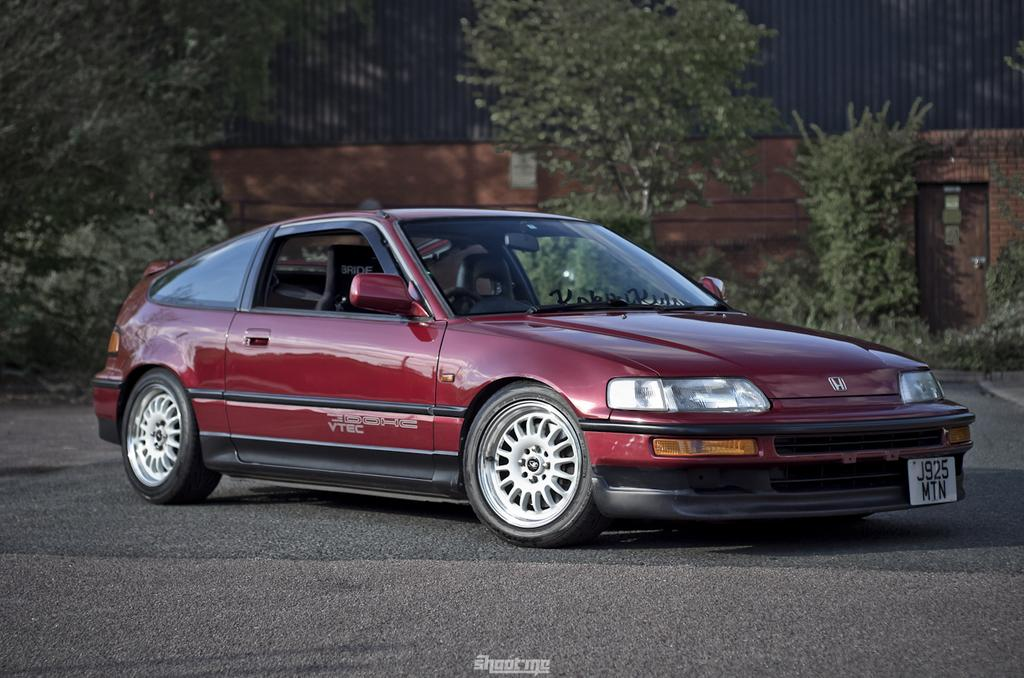What color is the car in the image? The car in the image is red. What is located at the bottom of the image? There is a road at the bottom of the image. What can be seen in the background of the image? There are plants and a wall in the background of the image. What type of health benefits can be gained from the camp in the image? There is no camp present in the image, so it is not possible to discuss any health benefits associated with it. 